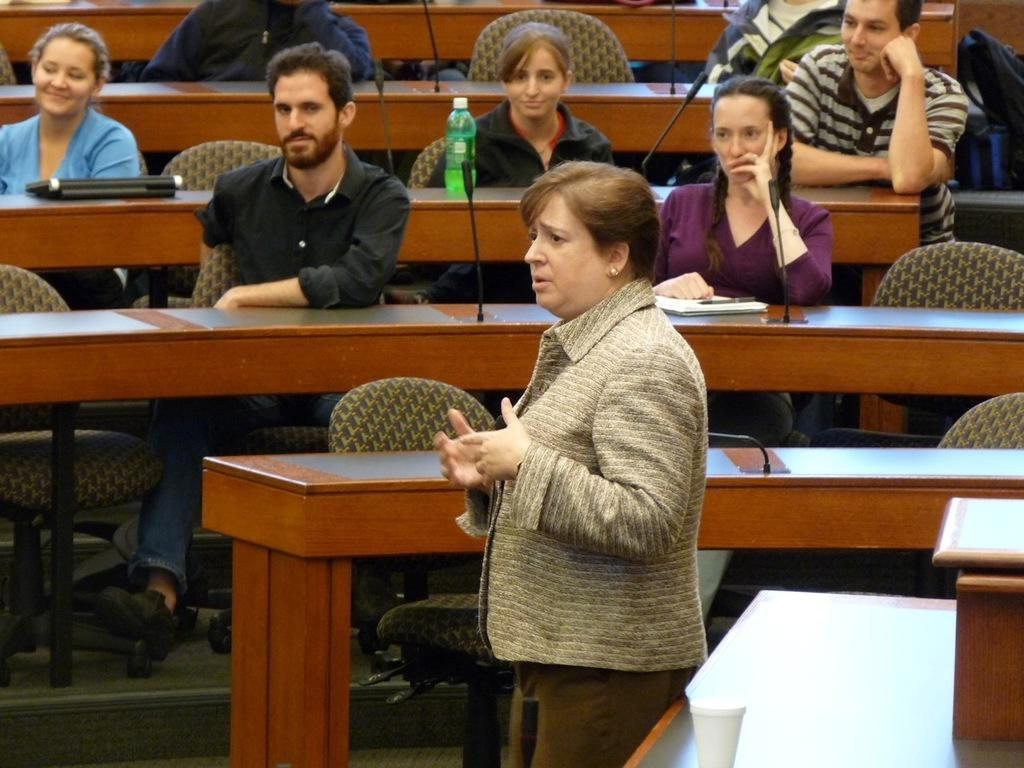What is the primary subject in the image? There is a woman standing in the image. What is located behind the woman? There are chairs behind the woman. What are the people on the chairs doing? People are seated on the chairs. What is in front of the chairs? There are tables in front of the chairs. What is on the tables? Mics are present on the tables. What type of copper coal can be seen on the woman's head in the image? There is no copper coal present in the image, nor is there any on the woman's head. 